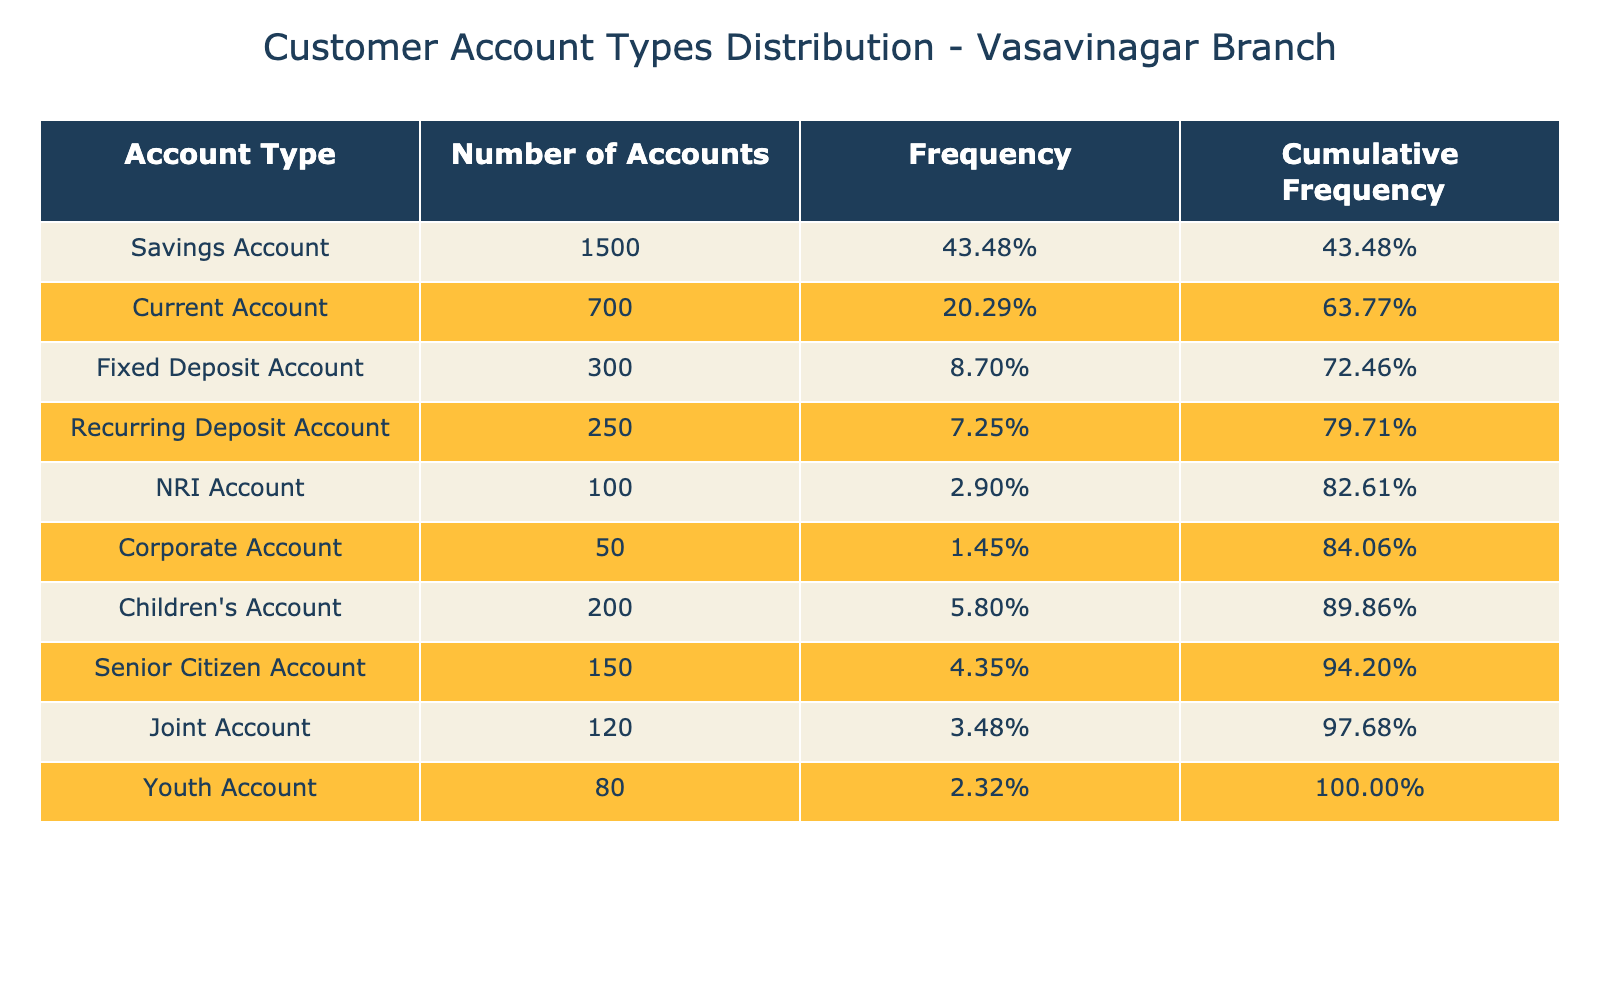What is the total number of accounts in the Vasavinagar branch? To find the total number of accounts, sum up all the values in the "Number of Accounts" column: 1500 + 700 + 300 + 250 + 100 + 50 + 200 + 150 + 120 + 80 = 3050.
Answer: 3050 Which account type has the highest number of accounts? By inspecting the "Number of Accounts" column, the highest value is 1500, corresponding to the "Savings Account".
Answer: Savings Account What percentage of total accounts do Current Accounts represent? The number of Current Accounts is 700. To find the percentage, divide 700 by the total number of accounts (3050) and multiply by 100: (700 / 3050) * 100 ≈ 22.95%.
Answer: 22.95% Does the bank have more Children's Accounts than NRI Accounts? Comparing the numbers, Children's Accounts total 200 while NRI Accounts total 100. Since 200 is greater than 100, the statement is true.
Answer: Yes What is the cumulative frequency for Fixed Deposit Accounts? The cumulative frequency is the sum of frequencies from the first account type up to Fixed Deposit Accounts. The frequencies are: Savings Account (1500), Current Account (700), and Fixed Deposit Account (300), which sums up to 1500/3050 + 700/3050 + 300/3050 = 60.66% when calculated properly and expressed cumulatively.
Answer: 60.66% How many more Savings Accounts are there than Joint Accounts? The number of Savings Accounts is 1500 and Joint Accounts is 120. The difference is 1500 - 120 = 1380.
Answer: 1380 What is the average number of accounts across all types? To find the average, sum the total number of accounts (3050) and divide by the number of account types (10): 3050 / 10 = 305.
Answer: 305 Are there more accounts for Senior Citizens than for Youth Accounts? Senior Citizen Accounts total 150 while Youth Accounts total 80. Since 150 is greater than 80, the answer is yes.
Answer: Yes 